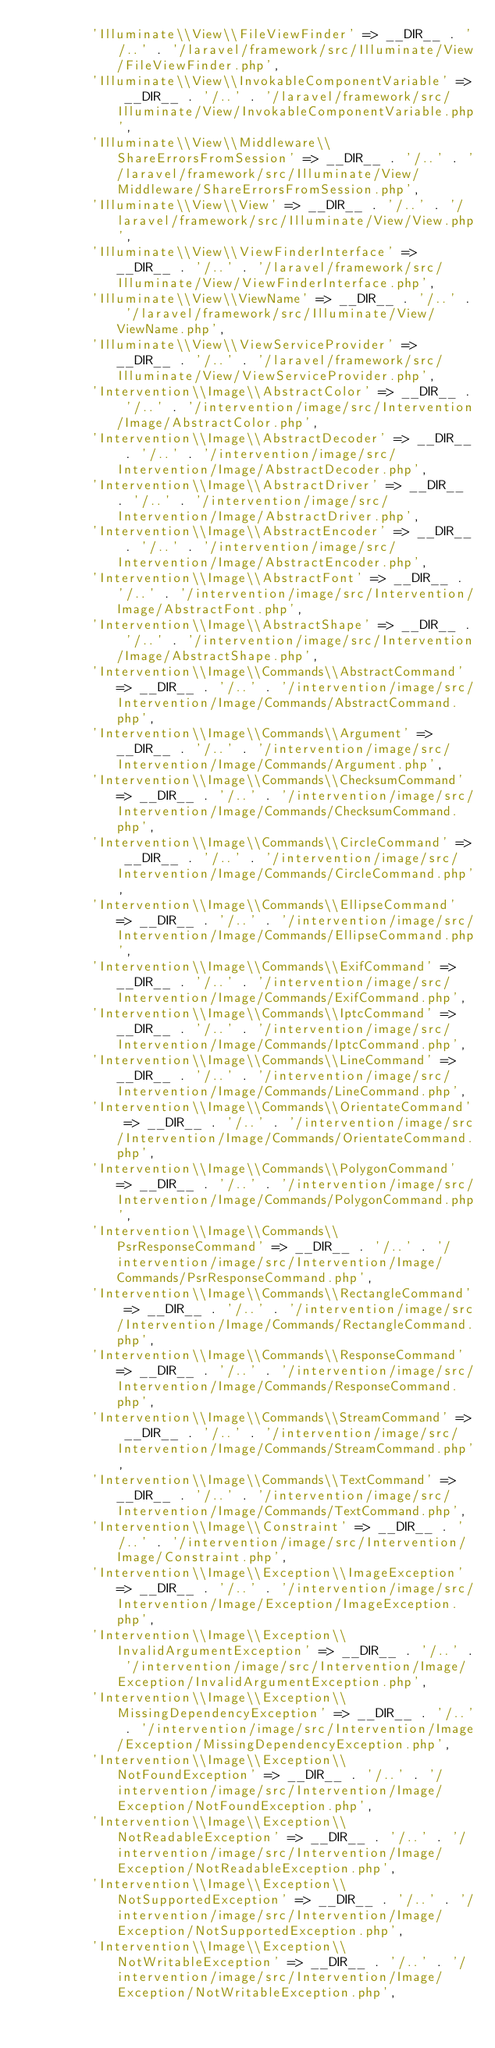Convert code to text. <code><loc_0><loc_0><loc_500><loc_500><_PHP_>        'Illuminate\\View\\FileViewFinder' => __DIR__ . '/..' . '/laravel/framework/src/Illuminate/View/FileViewFinder.php',
        'Illuminate\\View\\InvokableComponentVariable' => __DIR__ . '/..' . '/laravel/framework/src/Illuminate/View/InvokableComponentVariable.php',
        'Illuminate\\View\\Middleware\\ShareErrorsFromSession' => __DIR__ . '/..' . '/laravel/framework/src/Illuminate/View/Middleware/ShareErrorsFromSession.php',
        'Illuminate\\View\\View' => __DIR__ . '/..' . '/laravel/framework/src/Illuminate/View/View.php',
        'Illuminate\\View\\ViewFinderInterface' => __DIR__ . '/..' . '/laravel/framework/src/Illuminate/View/ViewFinderInterface.php',
        'Illuminate\\View\\ViewName' => __DIR__ . '/..' . '/laravel/framework/src/Illuminate/View/ViewName.php',
        'Illuminate\\View\\ViewServiceProvider' => __DIR__ . '/..' . '/laravel/framework/src/Illuminate/View/ViewServiceProvider.php',
        'Intervention\\Image\\AbstractColor' => __DIR__ . '/..' . '/intervention/image/src/Intervention/Image/AbstractColor.php',
        'Intervention\\Image\\AbstractDecoder' => __DIR__ . '/..' . '/intervention/image/src/Intervention/Image/AbstractDecoder.php',
        'Intervention\\Image\\AbstractDriver' => __DIR__ . '/..' . '/intervention/image/src/Intervention/Image/AbstractDriver.php',
        'Intervention\\Image\\AbstractEncoder' => __DIR__ . '/..' . '/intervention/image/src/Intervention/Image/AbstractEncoder.php',
        'Intervention\\Image\\AbstractFont' => __DIR__ . '/..' . '/intervention/image/src/Intervention/Image/AbstractFont.php',
        'Intervention\\Image\\AbstractShape' => __DIR__ . '/..' . '/intervention/image/src/Intervention/Image/AbstractShape.php',
        'Intervention\\Image\\Commands\\AbstractCommand' => __DIR__ . '/..' . '/intervention/image/src/Intervention/Image/Commands/AbstractCommand.php',
        'Intervention\\Image\\Commands\\Argument' => __DIR__ . '/..' . '/intervention/image/src/Intervention/Image/Commands/Argument.php',
        'Intervention\\Image\\Commands\\ChecksumCommand' => __DIR__ . '/..' . '/intervention/image/src/Intervention/Image/Commands/ChecksumCommand.php',
        'Intervention\\Image\\Commands\\CircleCommand' => __DIR__ . '/..' . '/intervention/image/src/Intervention/Image/Commands/CircleCommand.php',
        'Intervention\\Image\\Commands\\EllipseCommand' => __DIR__ . '/..' . '/intervention/image/src/Intervention/Image/Commands/EllipseCommand.php',
        'Intervention\\Image\\Commands\\ExifCommand' => __DIR__ . '/..' . '/intervention/image/src/Intervention/Image/Commands/ExifCommand.php',
        'Intervention\\Image\\Commands\\IptcCommand' => __DIR__ . '/..' . '/intervention/image/src/Intervention/Image/Commands/IptcCommand.php',
        'Intervention\\Image\\Commands\\LineCommand' => __DIR__ . '/..' . '/intervention/image/src/Intervention/Image/Commands/LineCommand.php',
        'Intervention\\Image\\Commands\\OrientateCommand' => __DIR__ . '/..' . '/intervention/image/src/Intervention/Image/Commands/OrientateCommand.php',
        'Intervention\\Image\\Commands\\PolygonCommand' => __DIR__ . '/..' . '/intervention/image/src/Intervention/Image/Commands/PolygonCommand.php',
        'Intervention\\Image\\Commands\\PsrResponseCommand' => __DIR__ . '/..' . '/intervention/image/src/Intervention/Image/Commands/PsrResponseCommand.php',
        'Intervention\\Image\\Commands\\RectangleCommand' => __DIR__ . '/..' . '/intervention/image/src/Intervention/Image/Commands/RectangleCommand.php',
        'Intervention\\Image\\Commands\\ResponseCommand' => __DIR__ . '/..' . '/intervention/image/src/Intervention/Image/Commands/ResponseCommand.php',
        'Intervention\\Image\\Commands\\StreamCommand' => __DIR__ . '/..' . '/intervention/image/src/Intervention/Image/Commands/StreamCommand.php',
        'Intervention\\Image\\Commands\\TextCommand' => __DIR__ . '/..' . '/intervention/image/src/Intervention/Image/Commands/TextCommand.php',
        'Intervention\\Image\\Constraint' => __DIR__ . '/..' . '/intervention/image/src/Intervention/Image/Constraint.php',
        'Intervention\\Image\\Exception\\ImageException' => __DIR__ . '/..' . '/intervention/image/src/Intervention/Image/Exception/ImageException.php',
        'Intervention\\Image\\Exception\\InvalidArgumentException' => __DIR__ . '/..' . '/intervention/image/src/Intervention/Image/Exception/InvalidArgumentException.php',
        'Intervention\\Image\\Exception\\MissingDependencyException' => __DIR__ . '/..' . '/intervention/image/src/Intervention/Image/Exception/MissingDependencyException.php',
        'Intervention\\Image\\Exception\\NotFoundException' => __DIR__ . '/..' . '/intervention/image/src/Intervention/Image/Exception/NotFoundException.php',
        'Intervention\\Image\\Exception\\NotReadableException' => __DIR__ . '/..' . '/intervention/image/src/Intervention/Image/Exception/NotReadableException.php',
        'Intervention\\Image\\Exception\\NotSupportedException' => __DIR__ . '/..' . '/intervention/image/src/Intervention/Image/Exception/NotSupportedException.php',
        'Intervention\\Image\\Exception\\NotWritableException' => __DIR__ . '/..' . '/intervention/image/src/Intervention/Image/Exception/NotWritableException.php',</code> 